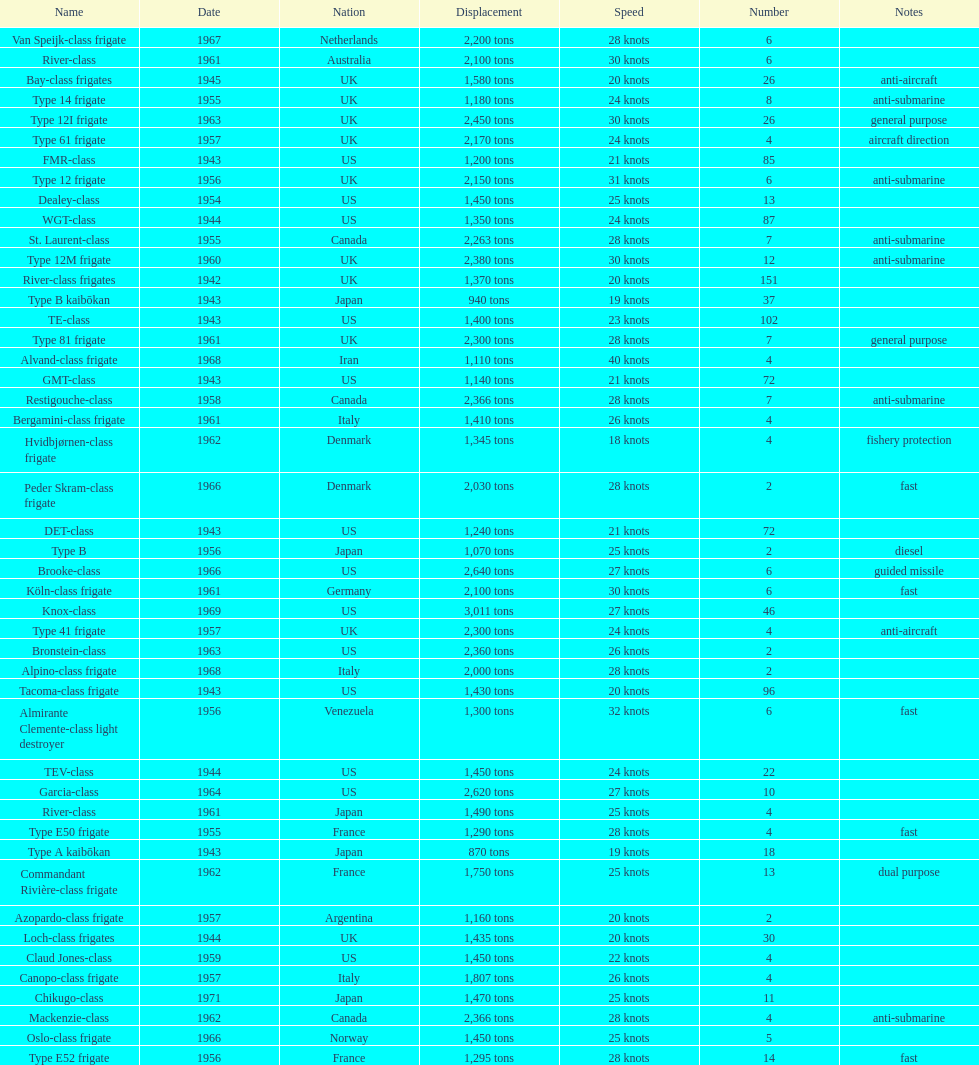What is the top speed? 40 knots. 